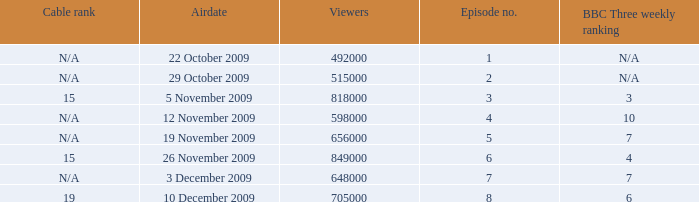How many entries are shown for viewers when the airdate was 26 november 2009? 1.0. 